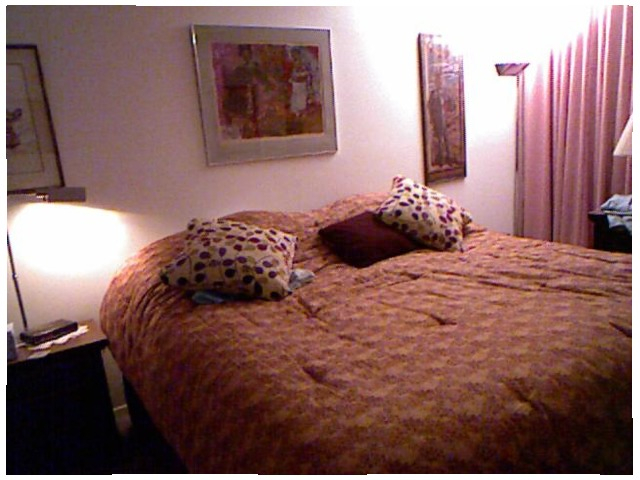<image>
Is the pillow on the bed? Yes. Looking at the image, I can see the pillow is positioned on top of the bed, with the bed providing support. 